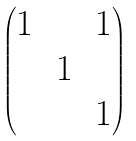<formula> <loc_0><loc_0><loc_500><loc_500>\begin{pmatrix} 1 & & 1 \\ & \, 1 \, & \\ & & 1 \end{pmatrix}</formula> 